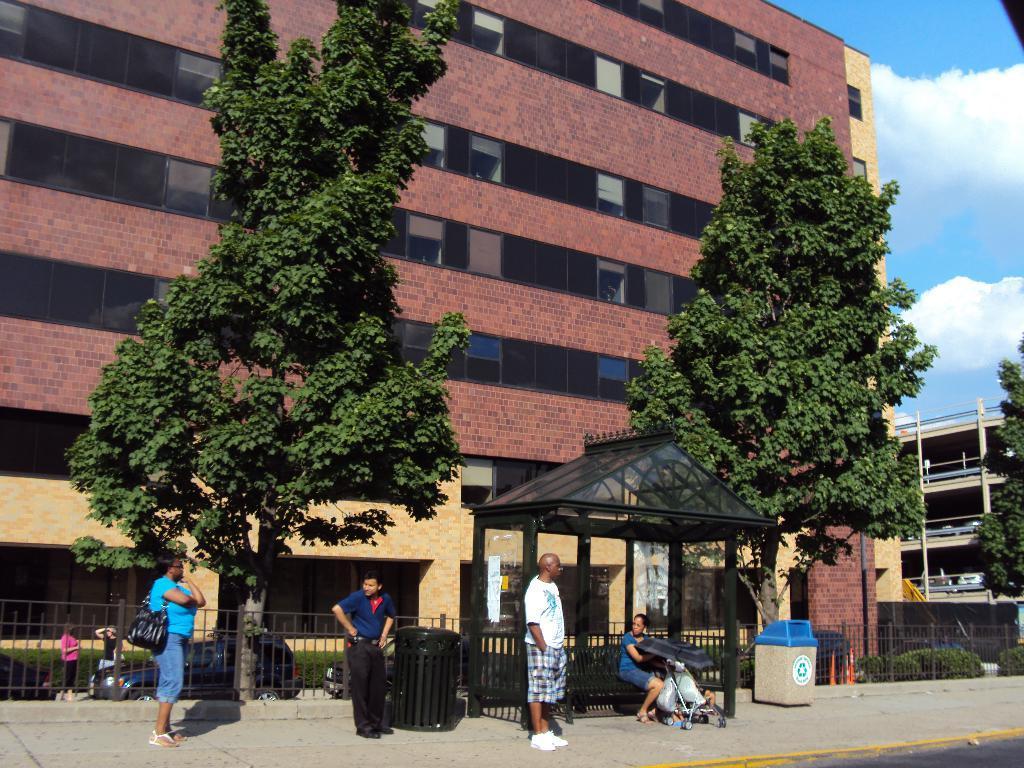Could you give a brief overview of what you see in this image? In this picture I can see the metal grill fence. I can see trees. I can see green grass. I can see people standing on the walkway. I can see a person sitting on the bench. I can see the buildings. I can see clouds in the sky. 